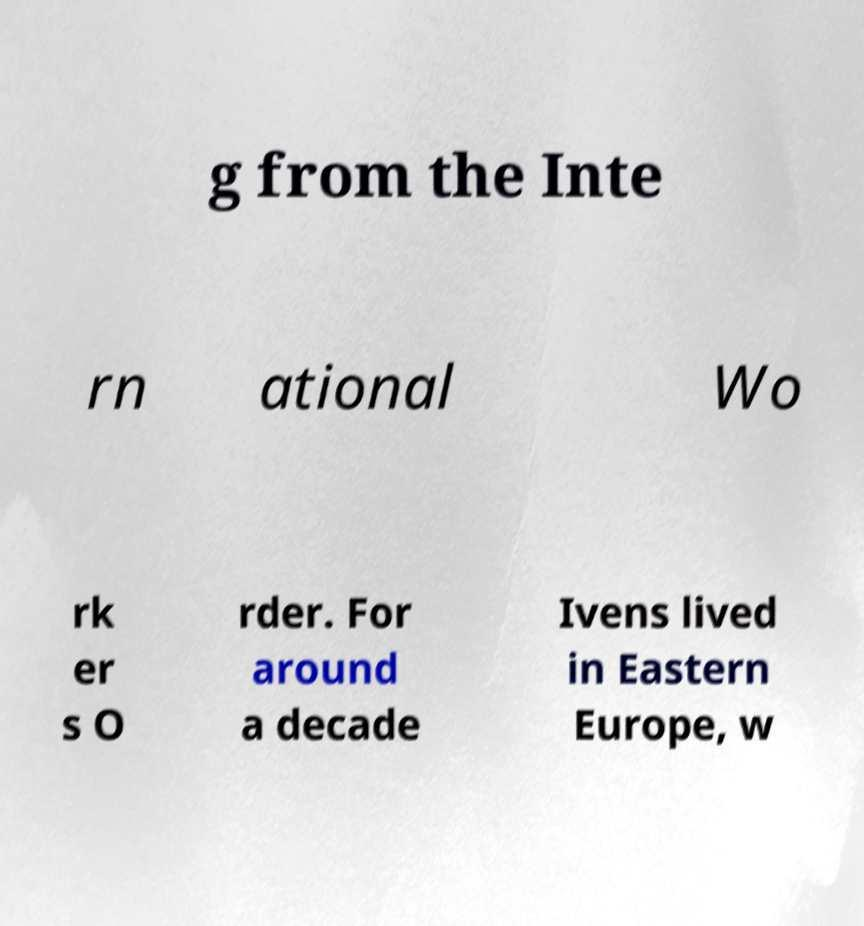There's text embedded in this image that I need extracted. Can you transcribe it verbatim? g from the Inte rn ational Wo rk er s O rder. For around a decade Ivens lived in Eastern Europe, w 